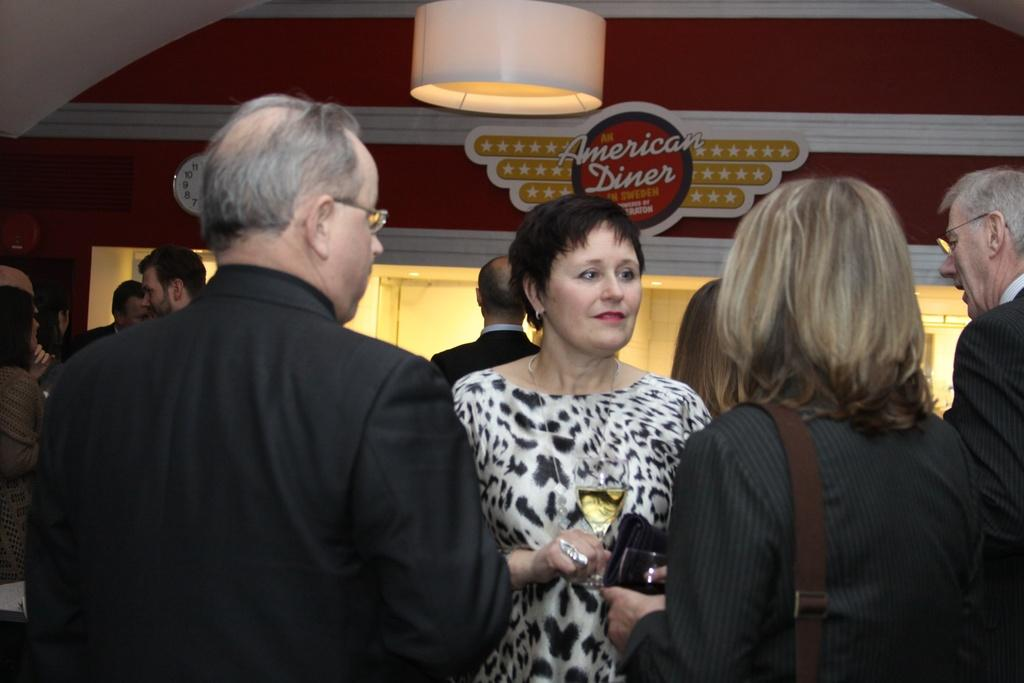How many people are in the image? There is a group of people in the image. What are two people doing with their hands? Two people are holding glasses with their hands. What can be seen in the background of the image? There is a wall, lights, a name board, and some objects in the background of the image. How many wounds can be seen on the mice in the image? There are no mice present in the image, so there are no wounds to count. What type of duck is visible in the image? There is no duck present in the image. 